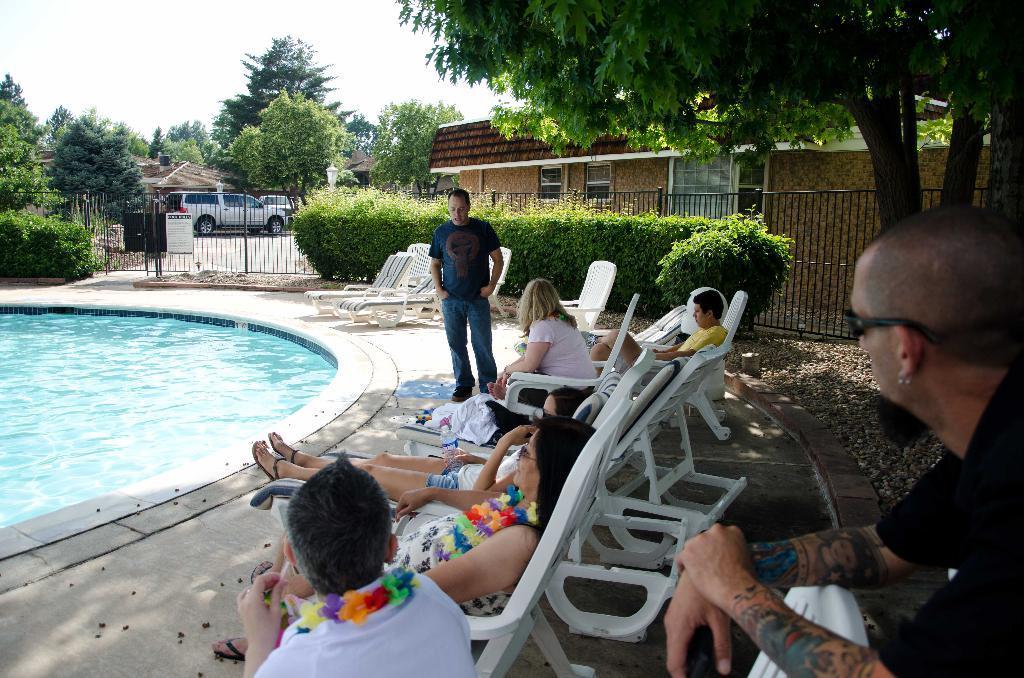Please provide a concise description of this image. In this picture we can see swimming pool and aside to this we have chairs and on chairs some persons are sitting and one person is standing and in the background we can see gate beside to this gate we have trees and after the gate there is car and here it is a building with windows and there is a fence to that building here on right side man is sitting wore goggles, black color T-Shirt and his hands are full of tattoos. 